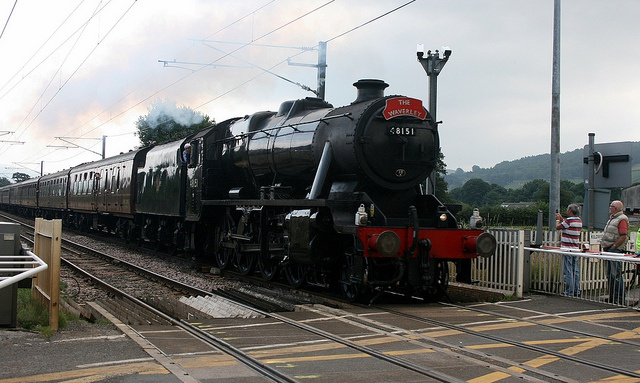Describe the objects in this image and their specific colors. I can see train in white, black, gray, darkgray, and lightgray tones, people in white, black, gray, maroon, and darkgray tones, people in white, gray, black, darkgray, and maroon tones, and cell phone in black, purple, gray, and white tones in this image. 